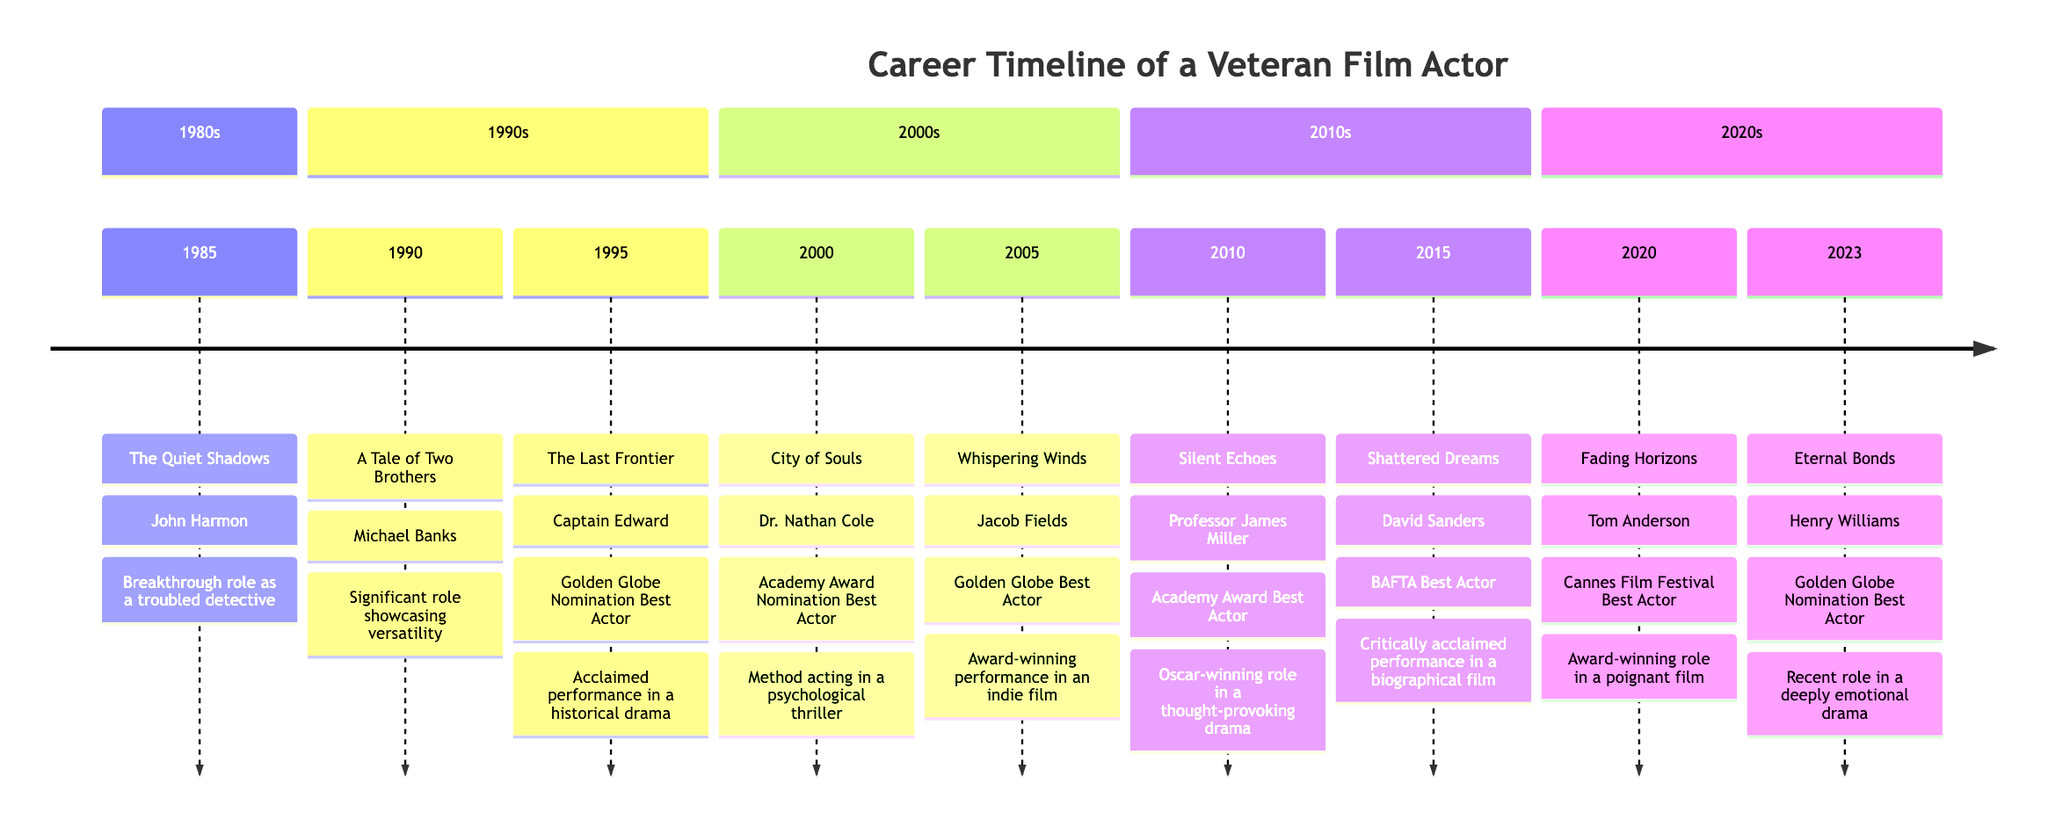What is the role played in the film "The Last Frontier"? In the timeline, under the year 1995, the film "The Last Frontier" lists the role as "Captain Edward."
Answer: Captain Edward What award did you receive for your role in "Silent Echoes"? Referring to the year 2010 in the timeline, the awards listed for "Silent Echoes" are "Academy Award Best Actor."
Answer: Academy Award Best Actor How many films are listed in the timeline for the 1980s? The only film from the 1980s in the timeline is "The Quiet Shadows," which makes a total of one film.
Answer: 1 Which film earned you a BAFTA Best Actor award? In the timeline under the year 2015, the film "Shattered Dreams" is associated with the BAFTA Best Actor award.
Answer: Shattered Dreams What is the significance of the role played in "Fading Horizons"? The notes for "Fading Horizons" in the year 2020 describe it as an "Award-winning role in a poignant film," indicating its significance.
Answer: Award-winning role in a poignant film In which year did you receive a nomination for a Golden Globe? The timeline shows that there is a "Golden Globe Nomination Best Actor" for the film "Eternal Bonds," which is from the year 2023.
Answer: 2023 What common theme can be identified in the films awarded in the 2010s? Noting that both films "Silent Echoes" (Academy Award) and "Shattered Dreams" (BAFTA) were critically acclaimed, a common theme is awards for dramatic performances.
Answer: Dramatic performances Which role was associated with a psychological thriller in the timeline? Pertaining to the year 2000, the role "Dr. Nathan Cole" in the film "City of Souls" is described as part of a psychological thriller.
Answer: Dr. Nathan Cole How many awards did you receive in the year 2005? The timeline indicates that the only award in 2005 was "Golden Globe Best Actor," leading to a total of one award received that year.
Answer: 1 